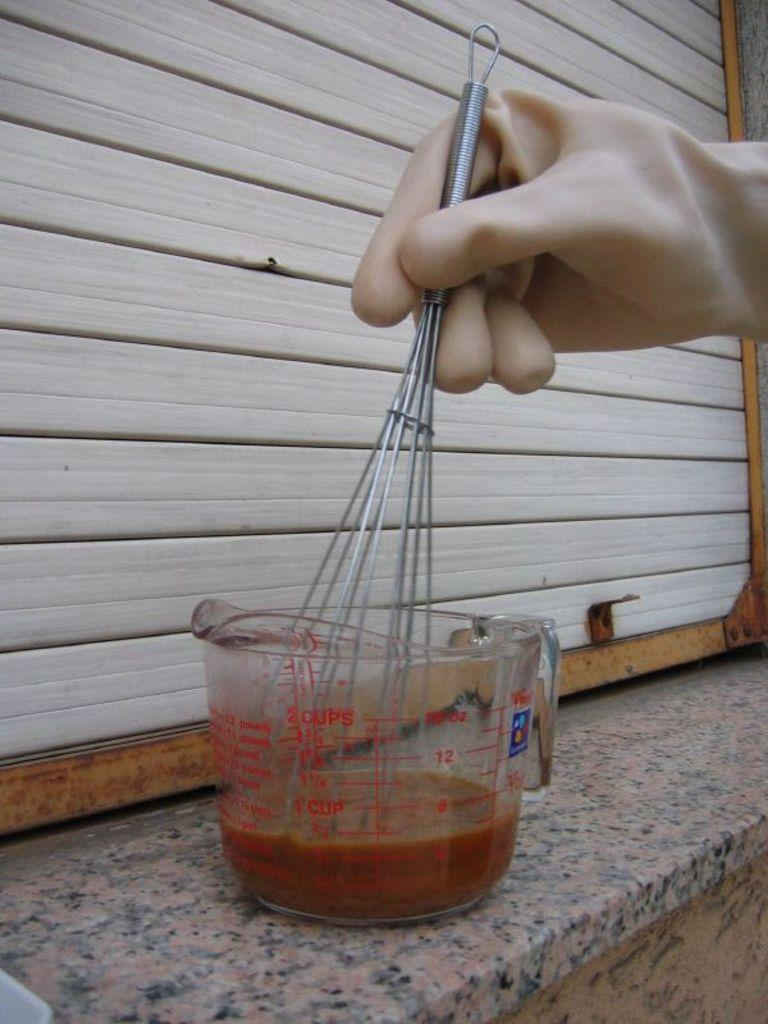What is the hand holding in the image? The hand is holding gloves in the image. What is the hand doing with the gloves on? The hand is mixing liquid in a glass beaker while wearing the gloves. Where is the glass beaker located? The glass beaker is on a shelf. How does the hand play with the chain in the image? There is no chain present in the image; the hand is mixing liquid in a glass beaker while wearing gloves. 